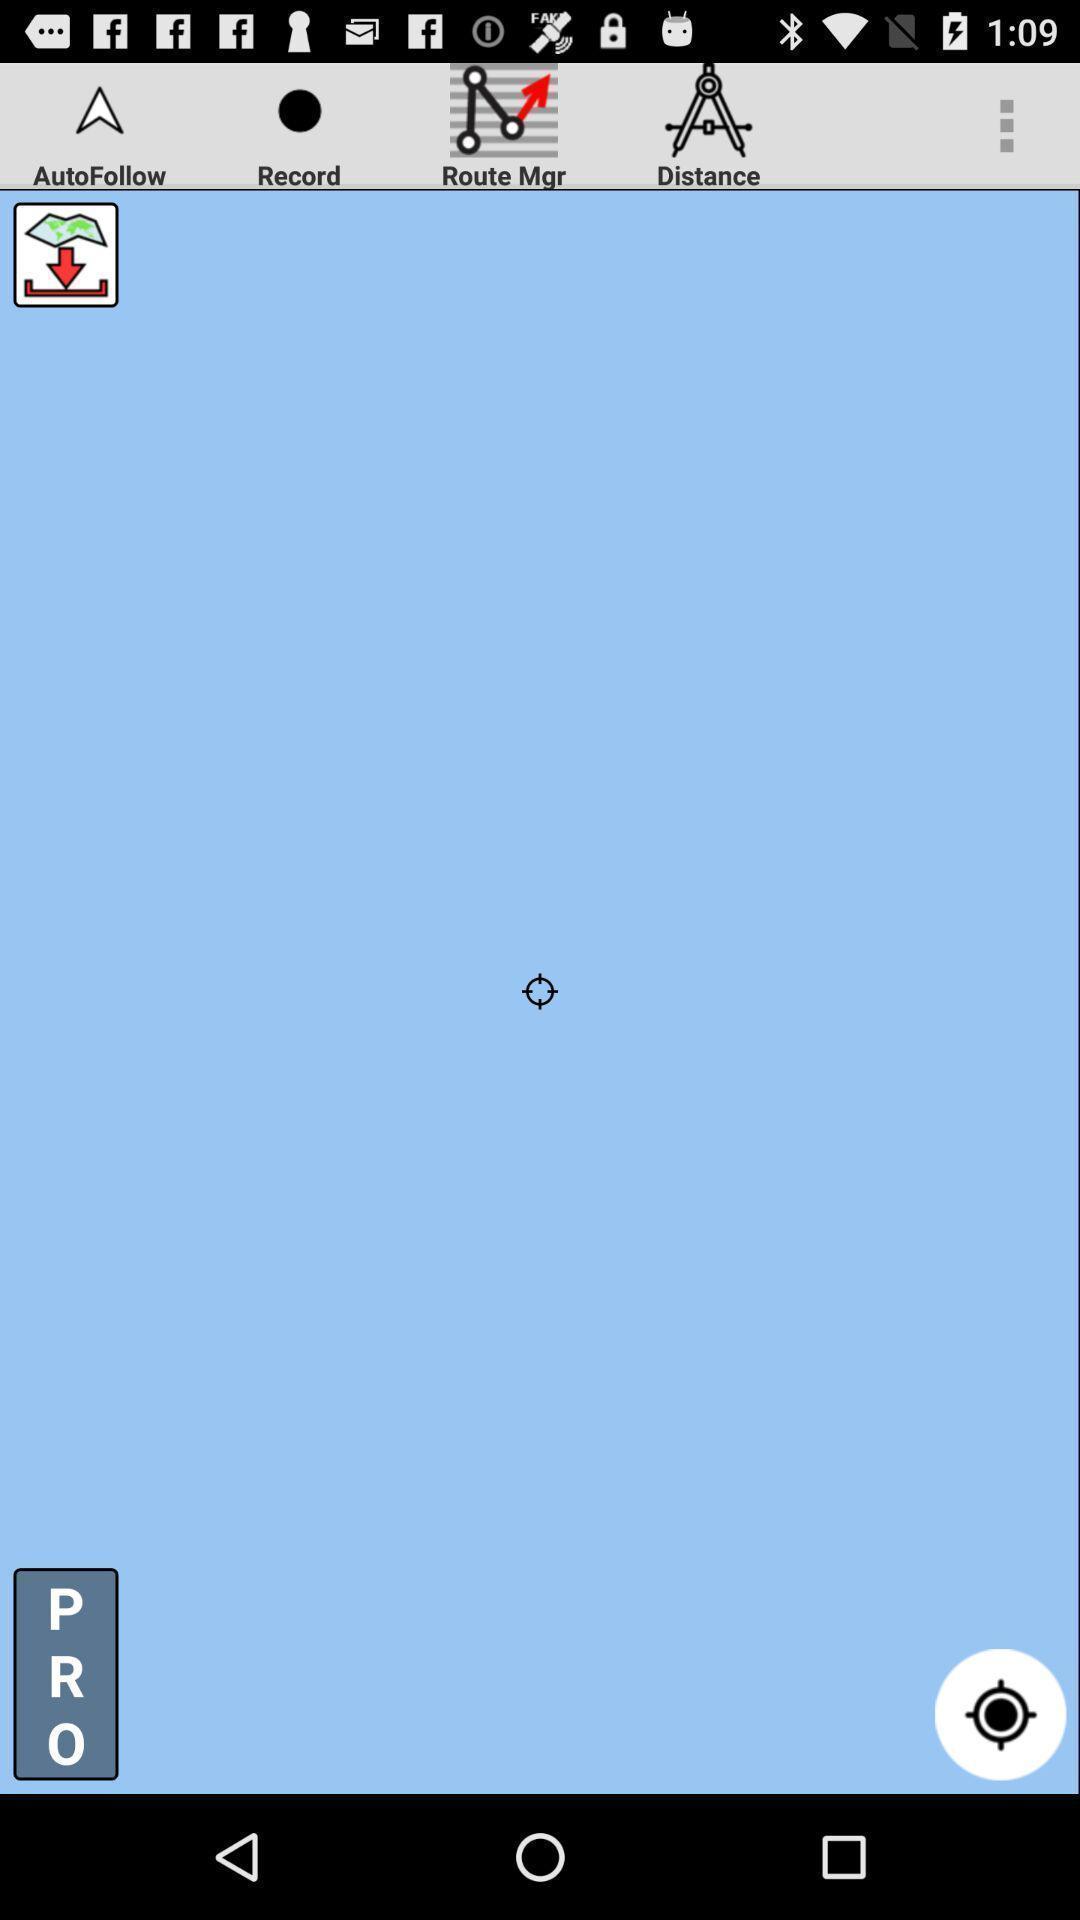Give me a summary of this screen capture. Screen page of a navigation app. 